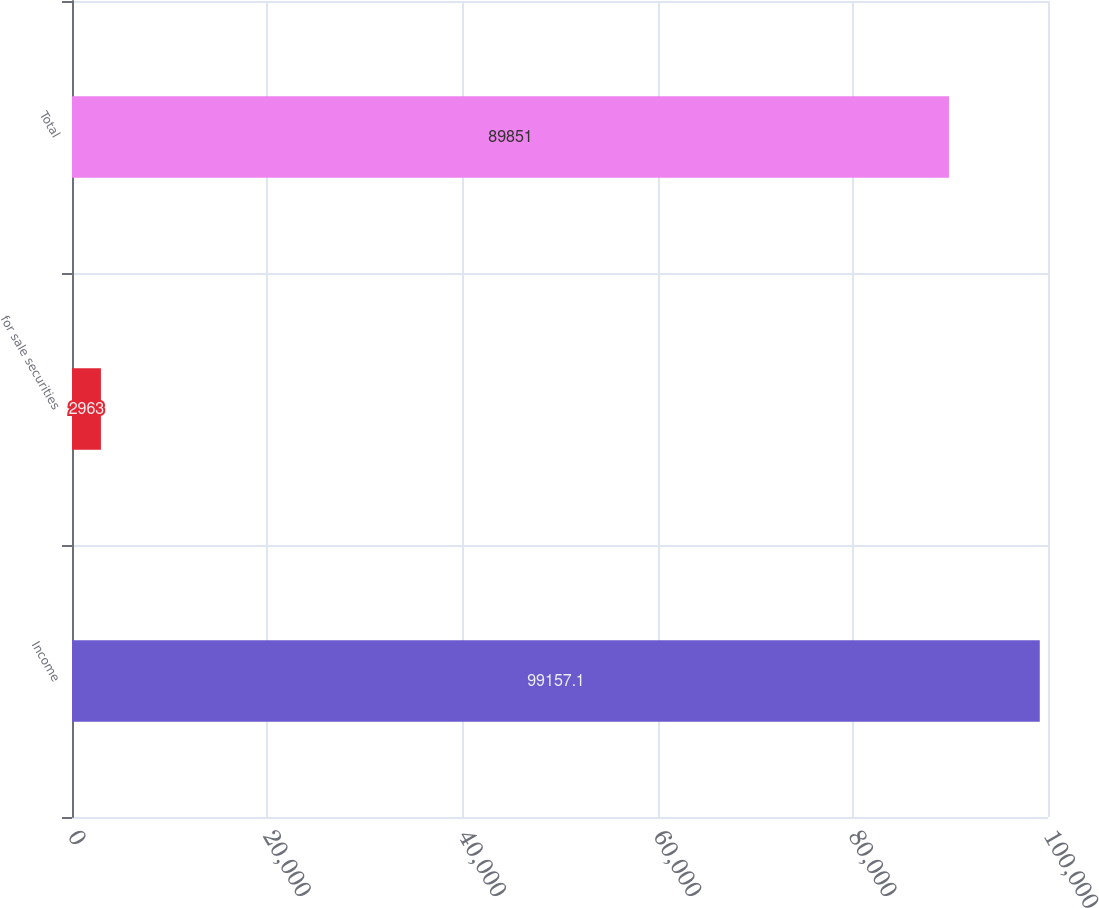Convert chart. <chart><loc_0><loc_0><loc_500><loc_500><bar_chart><fcel>Income<fcel>for sale securities<fcel>Total<nl><fcel>99157.1<fcel>2963<fcel>89851<nl></chart> 